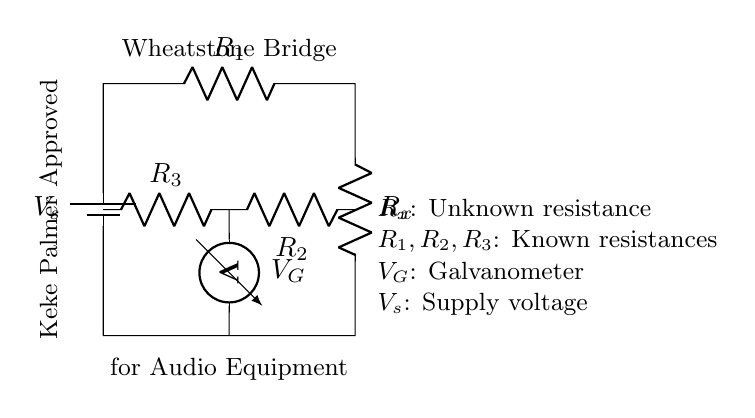What does the 'V_s' represent in the circuit? 'V_s' represents the supply voltage in the circuit, indicating the source of electrical energy.
Answer: Supply voltage What are the components 'R_1', 'R_2', 'R_3'? 'R_1', 'R_2', and 'R_3' are known resistances that are used to balance the Wheatstone bridge for precise resistance measurement.
Answer: Known resistances What is indicated by 'V_G' in the diagram? 'V_G' represents the galvanometer which measures the voltage difference across the bridge to determine balance.
Answer: Galvanometer How many resistors are in this Wheatstone bridge circuit? There are three resistors in the circuit, 'R_1', 'R_2', and 'R_3', along with the unknown resistor 'R_x'.
Answer: Three resistors What happens when the bridge is balanced? When the bridge is balanced, the voltage across the galvanometer ('V_G') is zero, indicating that 'R_x' is equal to the ratio of 'R_1', 'R_2', and 'R_3'.
Answer: Voltage zero What does 'R_x' stand for in the context of this bridge? 'R_x' stands for the unknown resistance that is being measured using the balanced Wheatstone bridge method.
Answer: Unknown resistance Why is the Wheatstone bridge used in audio equipment? The Wheatstone bridge is used for its precision in measuring resistance, which is crucial for ensuring accurate and high-quality audio performance.
Answer: Precision measurement 